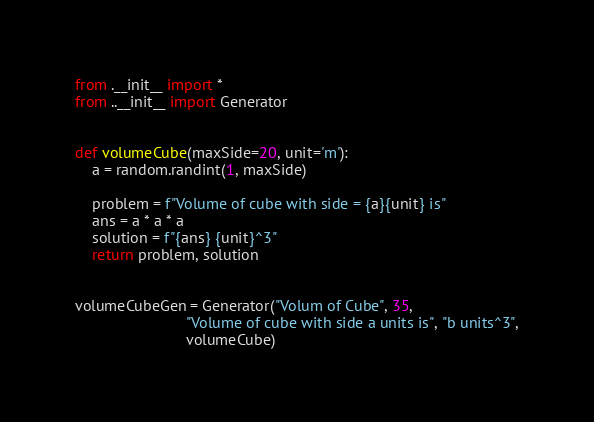<code> <loc_0><loc_0><loc_500><loc_500><_Python_>from .__init__ import *
from ..__init__ import Generator


def volumeCube(maxSide=20, unit='m'):
    a = random.randint(1, maxSide)

    problem = f"Volume of cube with side = {a}{unit} is"
    ans = a * a * a
    solution = f"{ans} {unit}^3"
    return problem, solution


volumeCubeGen = Generator("Volum of Cube", 35,
                          "Volume of cube with side a units is", "b units^3",
                          volumeCube)
</code> 